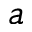<formula> <loc_0><loc_0><loc_500><loc_500>^ { a }</formula> 